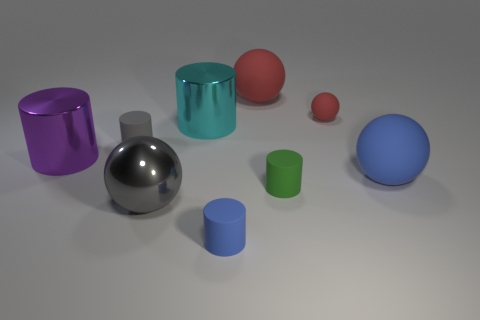Subtract 2 cylinders. How many cylinders are left? 3 Subtract all small gray cylinders. How many cylinders are left? 4 Subtract all green cylinders. How many cylinders are left? 4 Subtract all yellow cylinders. Subtract all gray cubes. How many cylinders are left? 5 Add 1 gray matte cylinders. How many objects exist? 10 Subtract all balls. How many objects are left? 5 Add 6 tiny yellow matte blocks. How many tiny yellow matte blocks exist? 6 Subtract 1 green cylinders. How many objects are left? 8 Subtract all small red things. Subtract all red matte things. How many objects are left? 6 Add 6 shiny things. How many shiny things are left? 9 